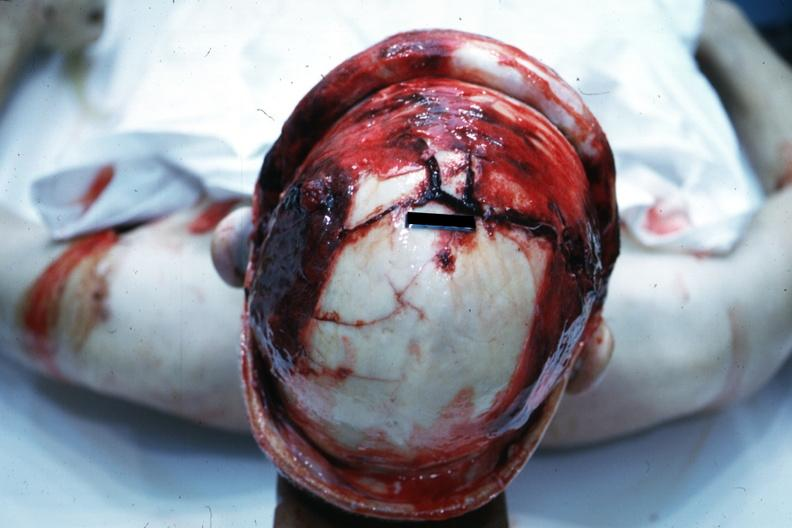how is view of head with scalp retracted to show fractures?
Answer the question using a single word or phrase. Massive 